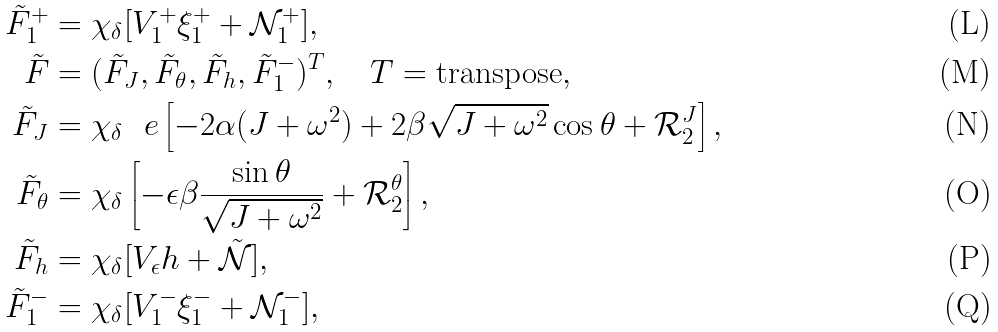<formula> <loc_0><loc_0><loc_500><loc_500>\tilde { F } ^ { + } _ { 1 } & = \chi _ { \delta } [ V ^ { + } _ { 1 } \xi ^ { + } _ { 1 } + \mathcal { N } ^ { + } _ { 1 } ] , \\ \tilde { F } & = ( \tilde { F } _ { J } , \tilde { F } _ { \theta } , \tilde { F } _ { h } , \tilde { F } ^ { - } _ { 1 } ) ^ { T } , \quad T = \text {transpose} , \\ \tilde { F } _ { J } & = \chi _ { \delta } \ \ e \left [ - 2 \alpha ( J + \omega ^ { 2 } ) + 2 \beta \sqrt { J + \omega ^ { 2 } } \cos \theta + \mathcal { R } ^ { J } _ { 2 } \right ] , \\ \tilde { F } _ { \theta } & = \chi _ { \delta } \left [ - \epsilon \beta \frac { \sin \theta } { \sqrt { J + \omega ^ { 2 } } } + \mathcal { R } ^ { \theta } _ { 2 } \right ] , \\ \tilde { F } _ { h } & = \chi _ { \delta } [ V _ { \epsilon } h + \tilde { \mathcal { N } } ] , \\ \tilde { F } _ { 1 } ^ { - } & = \chi _ { \delta } [ V ^ { - } _ { 1 } \xi ^ { - } _ { 1 } + \mathcal { N } ^ { - } _ { 1 } ] ,</formula> 